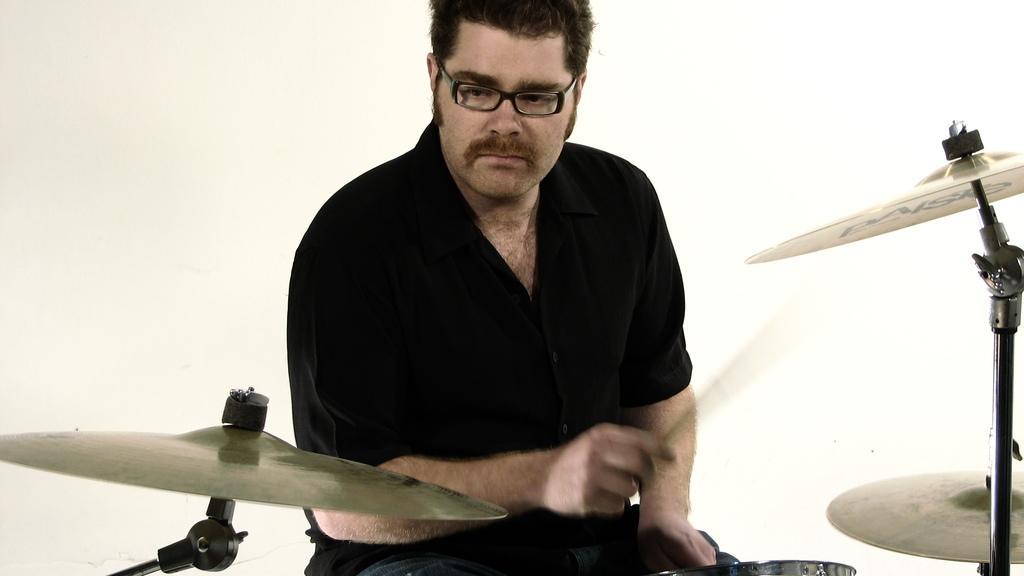Please provide a concise description of this image. In the image we can see a man sitting, wearing clothes, spectacle and the man is holding drumsticks in hand. Here we can see the musical instrument and the background is white. 